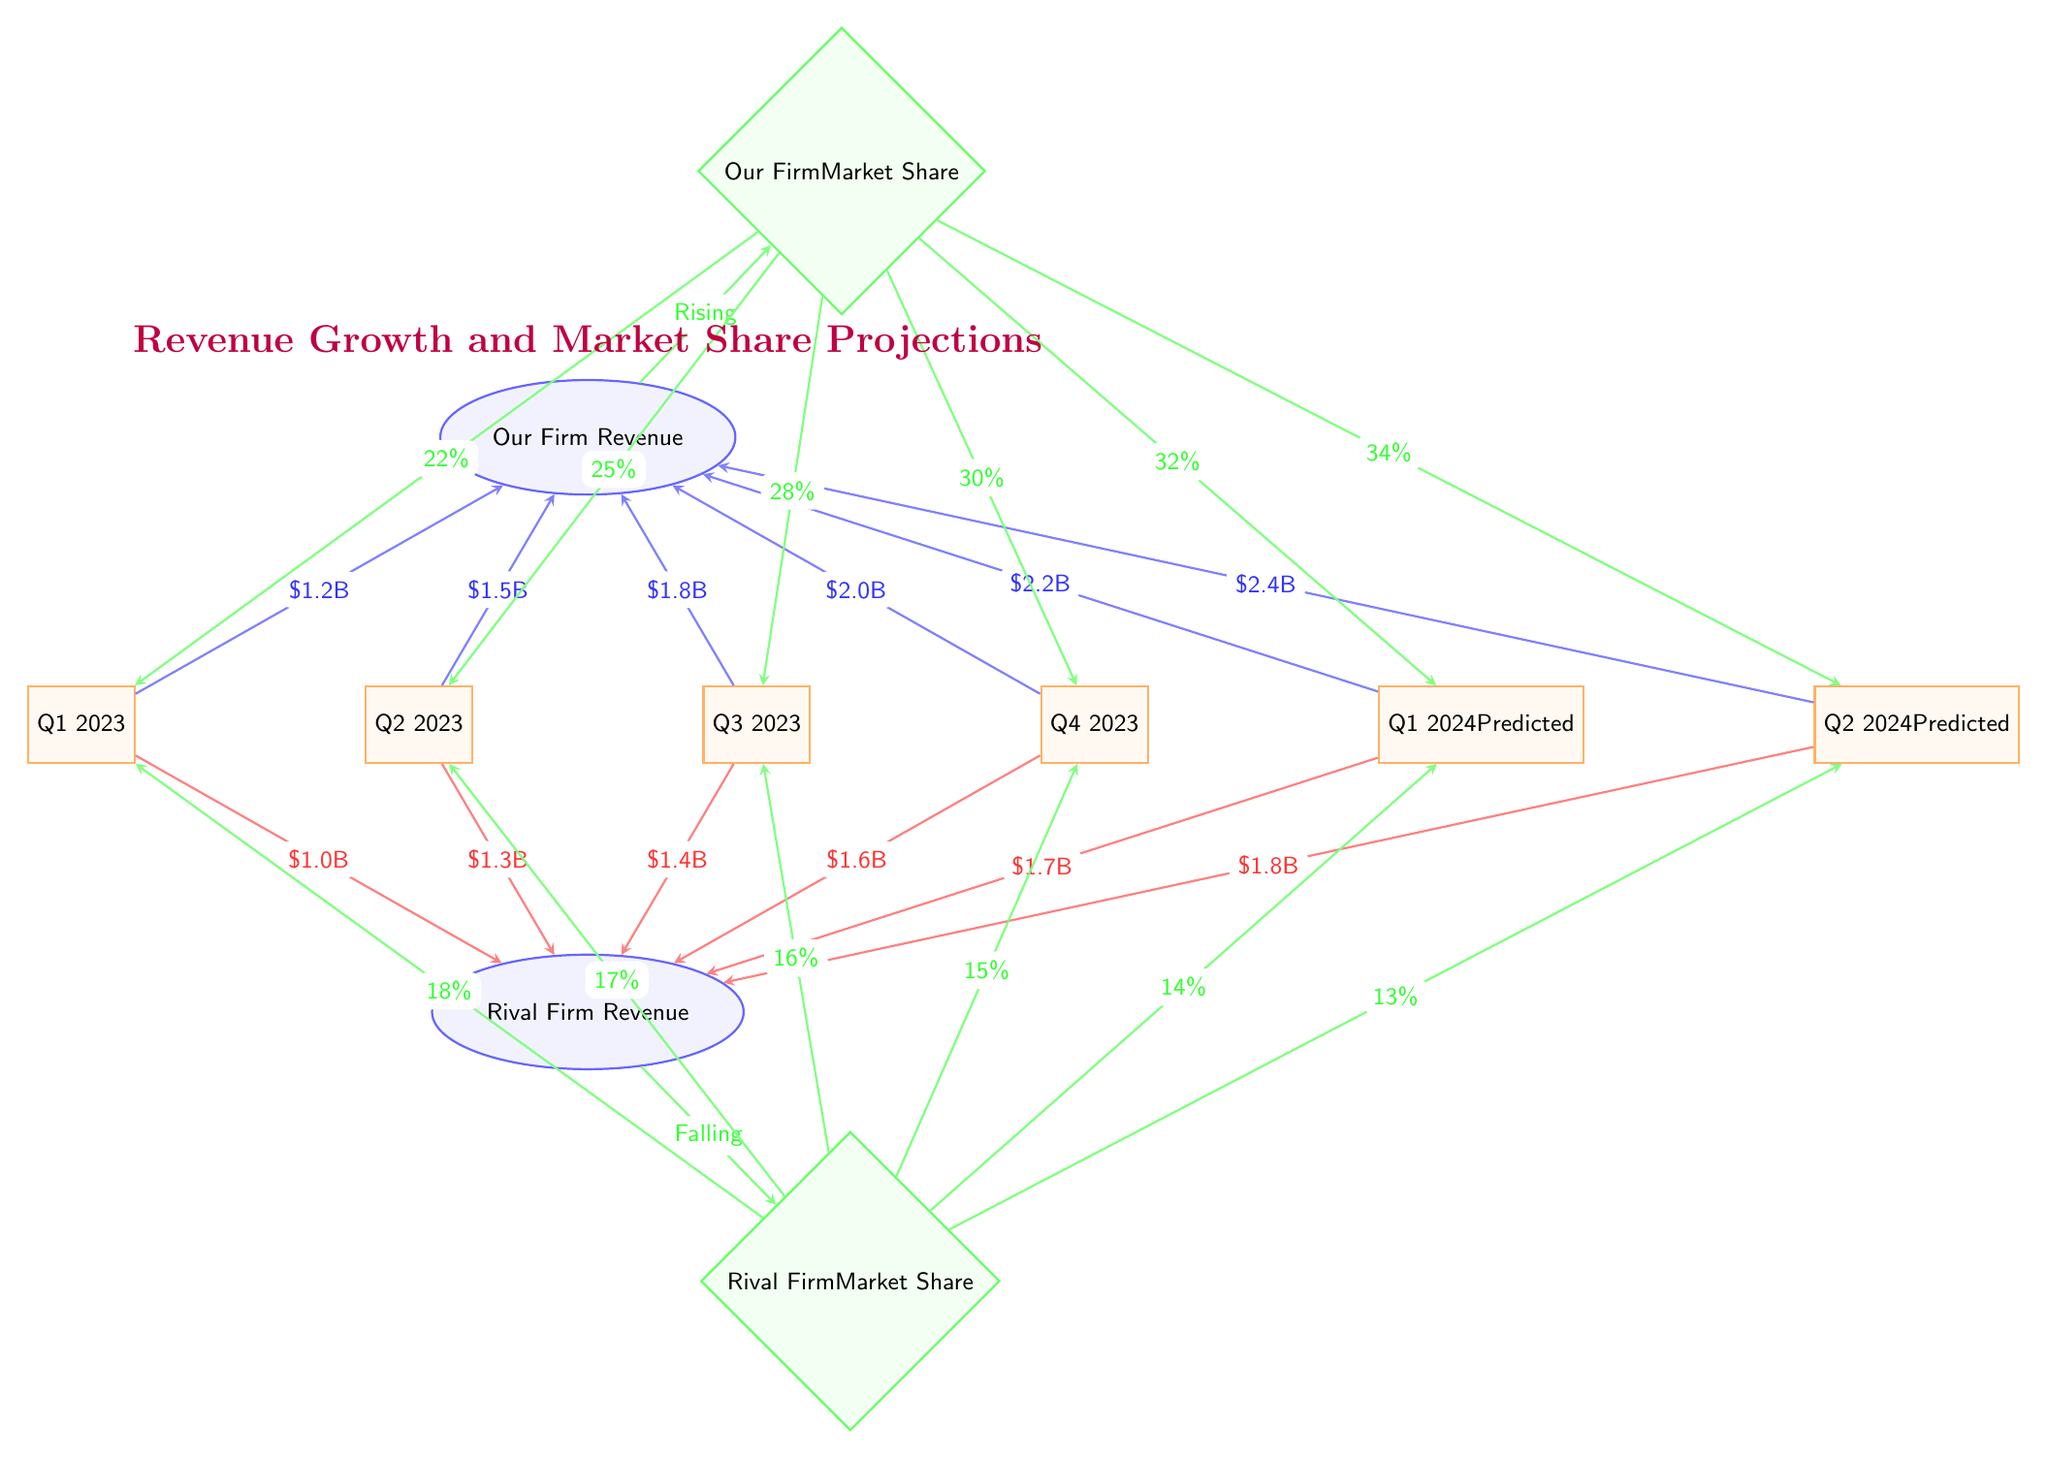What was the revenue of Our Firm in Q4 2023? The diagram shows an arrow from Q4 2023 to the Our Firm Revenue node, labeled with $2.0B. This indicates that the revenue for Our Firm in Q4 2023 was $2.0 billion.
Answer: $2.0B What is the market share percentage of the Rival Firm in Q1 2024? The diagram features an arrow from the Rival Firm Market Share to the Q1 2024 node, labeled with 14%. This represents the market share percentage of the Rival Firm in that quarter.
Answer: 14% How many quarters are projected in the diagram? The diagram includes nodes for Q1 2023 to Q2 2024, which totals six quarters including both actual and predicted data.
Answer: 6 What is the trend in Our Firm's revenue from Q1 2023 to Q2 2024? By examining the arrows pointing from each quarter to Our Firm Revenue, it shows an increasing trend from $1.2B to $2.4B, indicating consistent revenue growth.
Answer: Increasing What is the market share change for Our Firm from Q2 2023 to Q2 2024? The diagram indicates a market share of 25% in Q2 2023 and a projected 34% in Q2 2024. This shows an increase of 9 percentage points over the year.
Answer: 9% What is the revenue gap between Our Firm and the Rival Firm in Q3 2023? For Q3 2023, Our Firm’s revenue is $1.8B, while the Rival Firm’s revenue is $1.4B. The gap is calculated by subtracting the Rival Firm’s revenue from Our Firm’s revenue, resulting in a $0.4 billion difference.
Answer: $0.4B How does the Rival Firm's market share trend compare to Our Firm's from Q1 2023 to Q2 2024? Examining the arrows, Our Firm's market share rises from 22% to 34%, while the Rival Firm's market share falls from 18% to 13%, indicating a clear opposing trend between the two firms.
Answer: Opposing trends What is the projected revenue for Our Firm in Q1 2024? The arrow pointing to Q1 2024 in the Our Firm Revenue node is labeled with $2.2B, indicating that this is the projected revenue for that quarter.
Answer: $2.2B What does the diagonal green arrow between Our Firm Revenue and Our Firm Market Share indicate? This arrow, labeled "Rising", indicates that as revenue for Our Firm increases, the market share also rises, establishing a positive correlation between revenue and market share.
Answer: Rising 